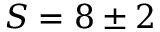<formula> <loc_0><loc_0><loc_500><loc_500>S = 8 \pm 2</formula> 